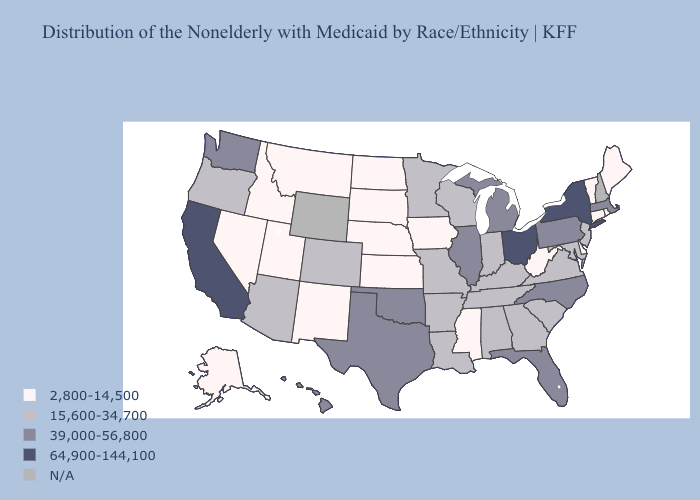Does Washington have the lowest value in the USA?
Concise answer only. No. Name the states that have a value in the range 64,900-144,100?
Concise answer only. California, New York, Ohio. Among the states that border Missouri , does Tennessee have the highest value?
Answer briefly. No. Which states hav the highest value in the South?
Concise answer only. Florida, North Carolina, Oklahoma, Texas. Name the states that have a value in the range 39,000-56,800?
Short answer required. Florida, Hawaii, Illinois, Massachusetts, Michigan, North Carolina, Oklahoma, Pennsylvania, Texas, Washington. Which states have the lowest value in the Northeast?
Write a very short answer. Connecticut, Maine, Rhode Island, Vermont. How many symbols are there in the legend?
Short answer required. 5. Name the states that have a value in the range 64,900-144,100?
Be succinct. California, New York, Ohio. Which states have the highest value in the USA?
Answer briefly. California, New York, Ohio. What is the value of New Hampshire?
Quick response, please. N/A. Name the states that have a value in the range 2,800-14,500?
Concise answer only. Alaska, Connecticut, Delaware, Idaho, Iowa, Kansas, Maine, Mississippi, Montana, Nebraska, Nevada, New Mexico, North Dakota, Rhode Island, South Dakota, Utah, Vermont, West Virginia. Does Arkansas have the highest value in the South?
Answer briefly. No. What is the lowest value in the USA?
Give a very brief answer. 2,800-14,500. 